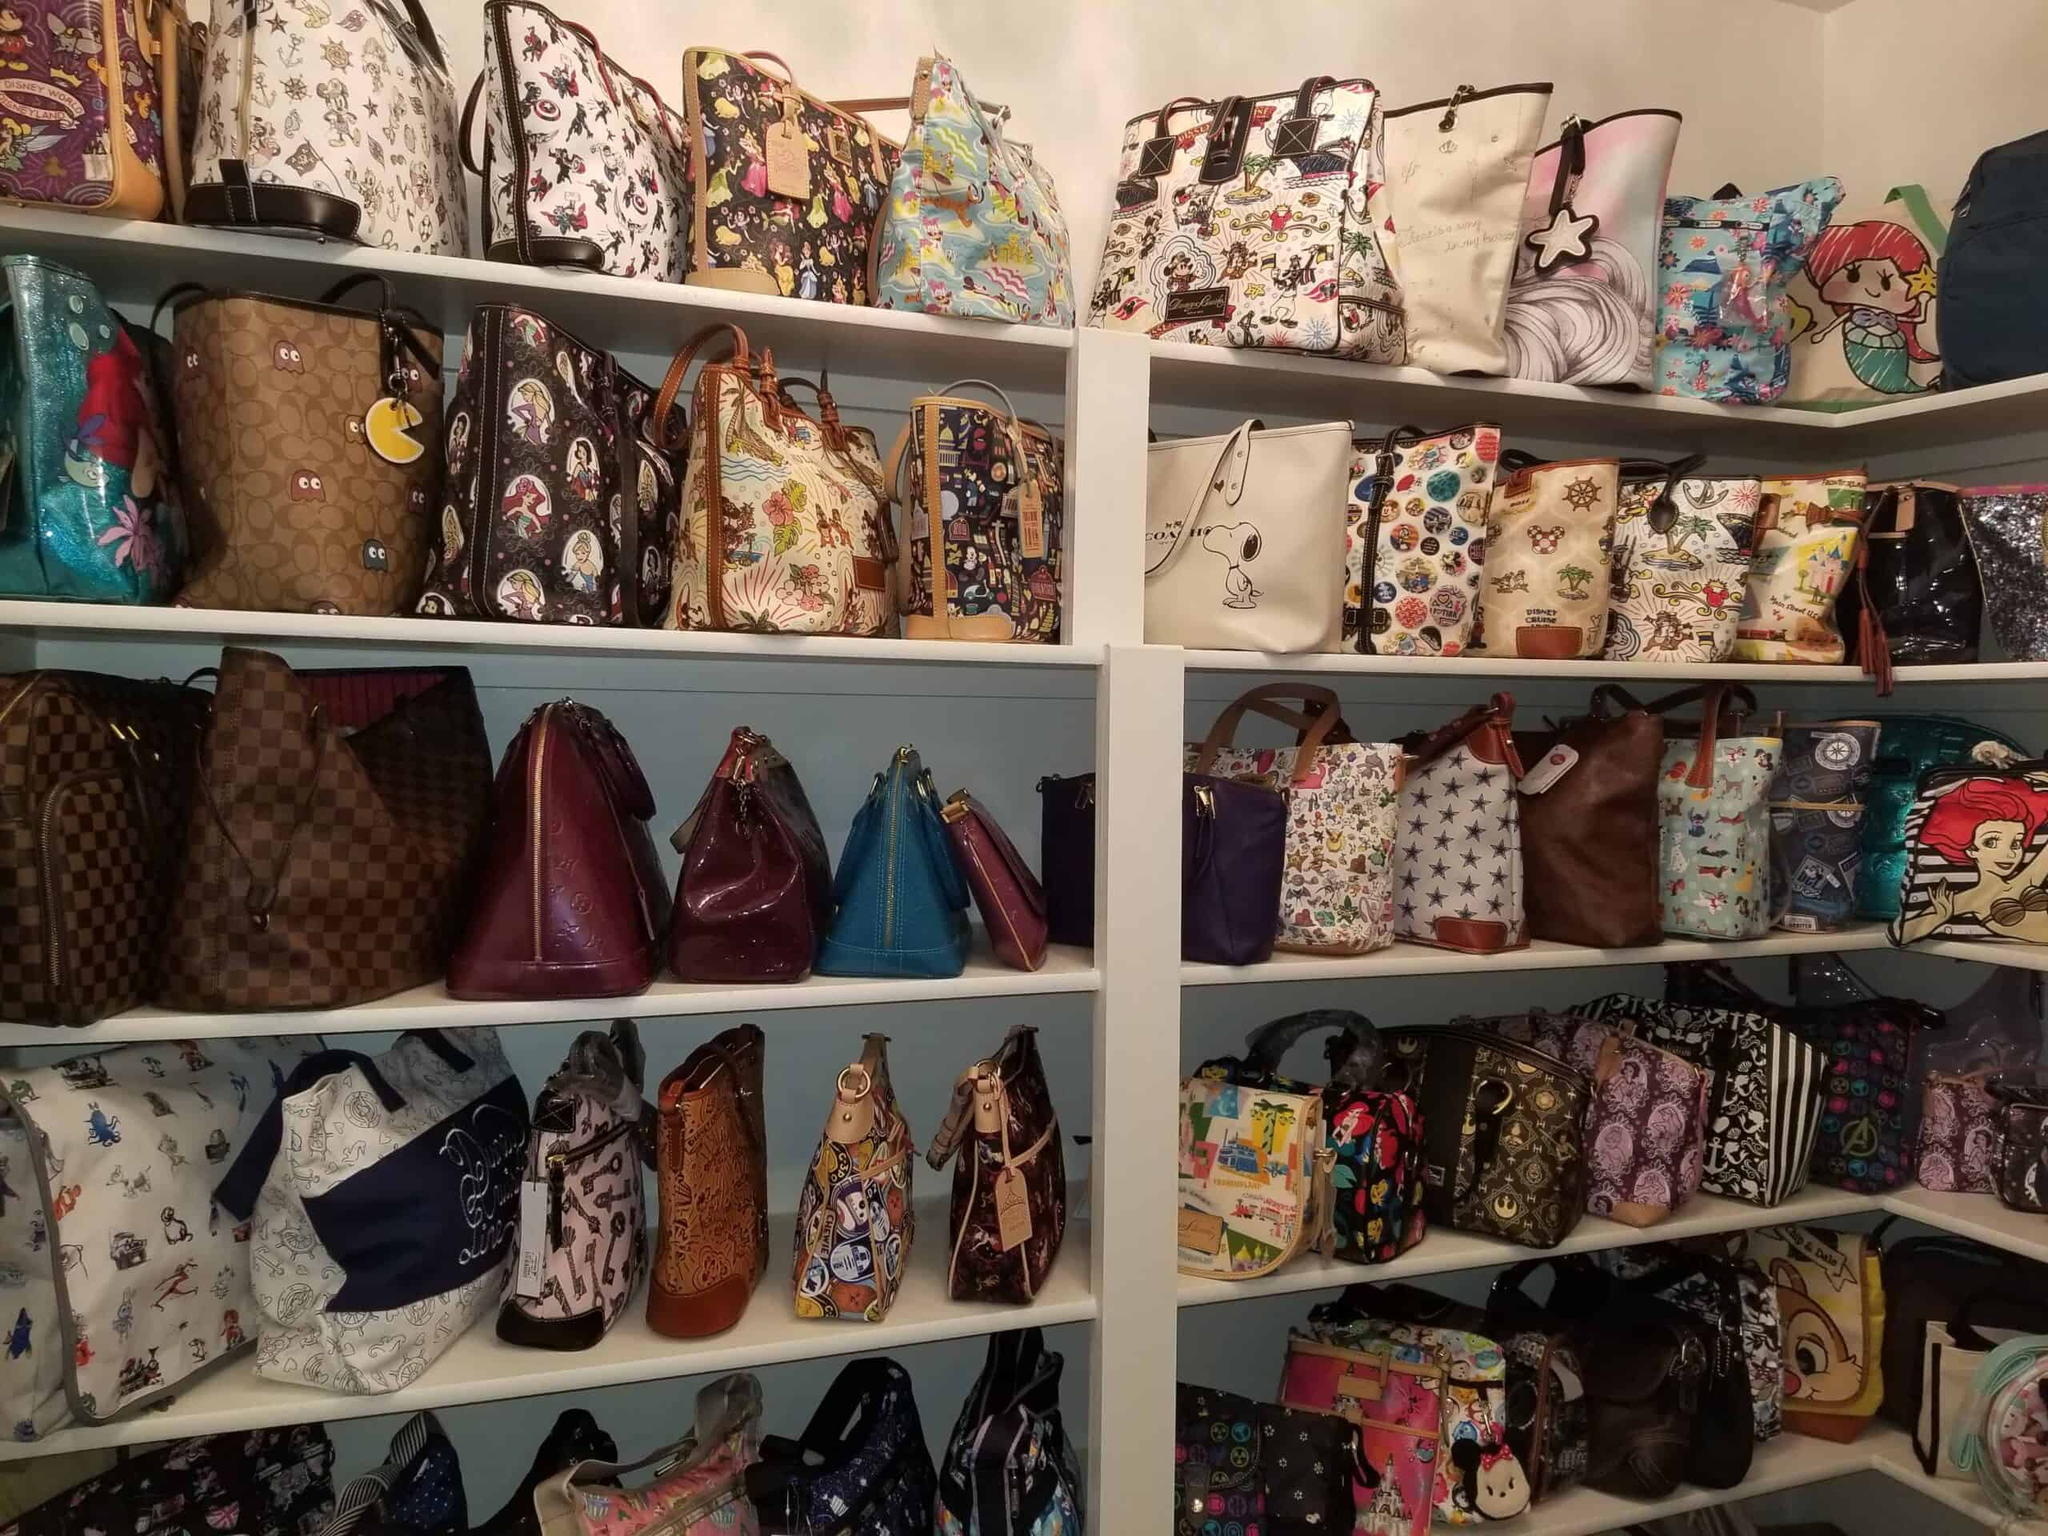Given the cartoon themes, what other accessories might complement these bags? Accessories that would complement these cartoon-themed bags could include matching keychains, vibrant scarves, and quirky pins that feature similar characters or themes. In addition, colorful phone cases, pop culture jewelry such as character earrings or bracelets, and even themed hats could enhance the playful look. Stationery items like themed notebooks or pen sets would also be a perfect match for fans who want to express their love for these characters in every aspect of their style. 